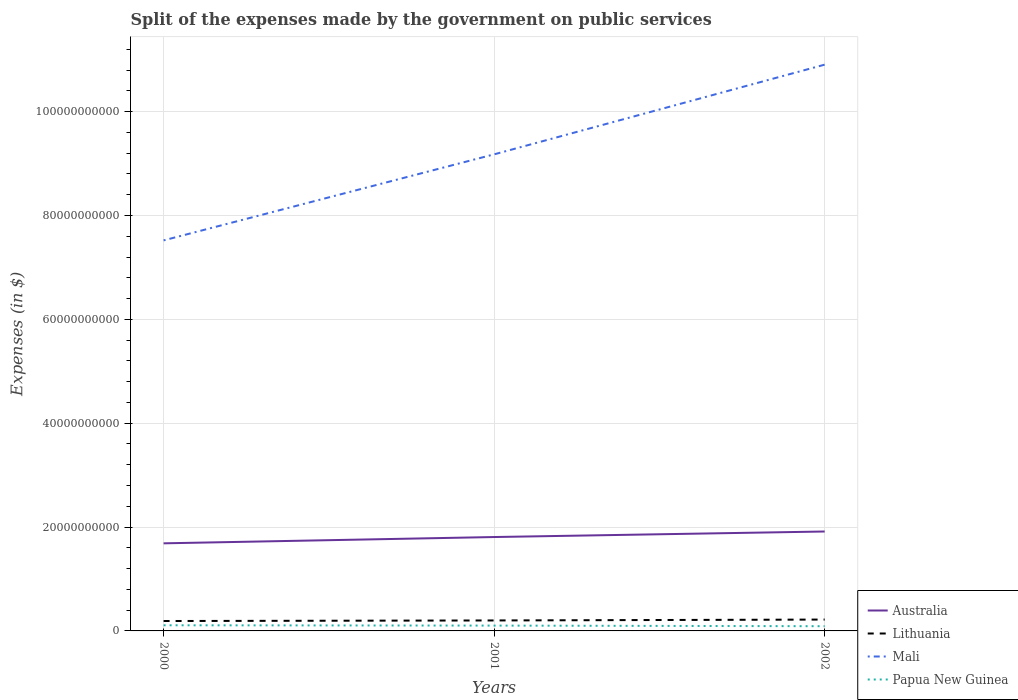How many different coloured lines are there?
Offer a terse response. 4. Across all years, what is the maximum expenses made by the government on public services in Mali?
Your answer should be compact. 7.52e+1. What is the total expenses made by the government on public services in Papua New Guinea in the graph?
Offer a terse response. 6.18e+07. What is the difference between the highest and the second highest expenses made by the government on public services in Australia?
Keep it short and to the point. 2.28e+09. What is the difference between the highest and the lowest expenses made by the government on public services in Papua New Guinea?
Your response must be concise. 2. Is the expenses made by the government on public services in Papua New Guinea strictly greater than the expenses made by the government on public services in Lithuania over the years?
Your response must be concise. Yes. What is the difference between two consecutive major ticks on the Y-axis?
Give a very brief answer. 2.00e+1. Are the values on the major ticks of Y-axis written in scientific E-notation?
Your answer should be compact. No. Does the graph contain grids?
Your answer should be very brief. Yes. Where does the legend appear in the graph?
Your answer should be compact. Bottom right. How are the legend labels stacked?
Give a very brief answer. Vertical. What is the title of the graph?
Your response must be concise. Split of the expenses made by the government on public services. Does "Andorra" appear as one of the legend labels in the graph?
Provide a succinct answer. No. What is the label or title of the X-axis?
Your response must be concise. Years. What is the label or title of the Y-axis?
Make the answer very short. Expenses (in $). What is the Expenses (in $) of Australia in 2000?
Make the answer very short. 1.69e+1. What is the Expenses (in $) in Lithuania in 2000?
Offer a terse response. 1.91e+09. What is the Expenses (in $) in Mali in 2000?
Your response must be concise. 7.52e+1. What is the Expenses (in $) of Papua New Guinea in 2000?
Offer a very short reply. 1.09e+09. What is the Expenses (in $) of Australia in 2001?
Provide a short and direct response. 1.81e+1. What is the Expenses (in $) in Lithuania in 2001?
Offer a very short reply. 2.02e+09. What is the Expenses (in $) in Mali in 2001?
Offer a terse response. 9.18e+1. What is the Expenses (in $) in Papua New Guinea in 2001?
Your response must be concise. 1.03e+09. What is the Expenses (in $) in Australia in 2002?
Give a very brief answer. 1.91e+1. What is the Expenses (in $) in Lithuania in 2002?
Provide a succinct answer. 2.19e+09. What is the Expenses (in $) of Mali in 2002?
Provide a short and direct response. 1.09e+11. What is the Expenses (in $) in Papua New Guinea in 2002?
Give a very brief answer. 9.07e+08. Across all years, what is the maximum Expenses (in $) in Australia?
Offer a terse response. 1.91e+1. Across all years, what is the maximum Expenses (in $) in Lithuania?
Your answer should be very brief. 2.19e+09. Across all years, what is the maximum Expenses (in $) of Mali?
Offer a terse response. 1.09e+11. Across all years, what is the maximum Expenses (in $) in Papua New Guinea?
Ensure brevity in your answer.  1.09e+09. Across all years, what is the minimum Expenses (in $) of Australia?
Keep it short and to the point. 1.69e+1. Across all years, what is the minimum Expenses (in $) in Lithuania?
Your answer should be compact. 1.91e+09. Across all years, what is the minimum Expenses (in $) of Mali?
Ensure brevity in your answer.  7.52e+1. Across all years, what is the minimum Expenses (in $) of Papua New Guinea?
Provide a succinct answer. 9.07e+08. What is the total Expenses (in $) in Australia in the graph?
Your answer should be compact. 5.41e+1. What is the total Expenses (in $) of Lithuania in the graph?
Your response must be concise. 6.11e+09. What is the total Expenses (in $) in Mali in the graph?
Offer a very short reply. 2.76e+11. What is the total Expenses (in $) of Papua New Guinea in the graph?
Offer a terse response. 3.02e+09. What is the difference between the Expenses (in $) of Australia in 2000 and that in 2001?
Make the answer very short. -1.21e+09. What is the difference between the Expenses (in $) in Lithuania in 2000 and that in 2001?
Provide a short and direct response. -1.09e+08. What is the difference between the Expenses (in $) of Mali in 2000 and that in 2001?
Keep it short and to the point. -1.66e+1. What is the difference between the Expenses (in $) in Papua New Guinea in 2000 and that in 2001?
Offer a very short reply. 6.18e+07. What is the difference between the Expenses (in $) in Australia in 2000 and that in 2002?
Ensure brevity in your answer.  -2.28e+09. What is the difference between the Expenses (in $) in Lithuania in 2000 and that in 2002?
Ensure brevity in your answer.  -2.80e+08. What is the difference between the Expenses (in $) in Mali in 2000 and that in 2002?
Provide a short and direct response. -3.38e+1. What is the difference between the Expenses (in $) of Papua New Guinea in 2000 and that in 2002?
Offer a very short reply. 1.80e+08. What is the difference between the Expenses (in $) of Australia in 2001 and that in 2002?
Offer a very short reply. -1.06e+09. What is the difference between the Expenses (in $) in Lithuania in 2001 and that in 2002?
Offer a terse response. -1.71e+08. What is the difference between the Expenses (in $) of Mali in 2001 and that in 2002?
Your answer should be very brief. -1.73e+1. What is the difference between the Expenses (in $) in Papua New Guinea in 2001 and that in 2002?
Provide a succinct answer. 1.18e+08. What is the difference between the Expenses (in $) of Australia in 2000 and the Expenses (in $) of Lithuania in 2001?
Provide a succinct answer. 1.49e+1. What is the difference between the Expenses (in $) in Australia in 2000 and the Expenses (in $) in Mali in 2001?
Offer a terse response. -7.49e+1. What is the difference between the Expenses (in $) in Australia in 2000 and the Expenses (in $) in Papua New Guinea in 2001?
Give a very brief answer. 1.58e+1. What is the difference between the Expenses (in $) of Lithuania in 2000 and the Expenses (in $) of Mali in 2001?
Your answer should be compact. -8.99e+1. What is the difference between the Expenses (in $) of Lithuania in 2000 and the Expenses (in $) of Papua New Guinea in 2001?
Your response must be concise. 8.82e+08. What is the difference between the Expenses (in $) of Mali in 2000 and the Expenses (in $) of Papua New Guinea in 2001?
Offer a terse response. 7.42e+1. What is the difference between the Expenses (in $) in Australia in 2000 and the Expenses (in $) in Lithuania in 2002?
Your response must be concise. 1.47e+1. What is the difference between the Expenses (in $) of Australia in 2000 and the Expenses (in $) of Mali in 2002?
Offer a very short reply. -9.22e+1. What is the difference between the Expenses (in $) in Australia in 2000 and the Expenses (in $) in Papua New Guinea in 2002?
Make the answer very short. 1.60e+1. What is the difference between the Expenses (in $) of Lithuania in 2000 and the Expenses (in $) of Mali in 2002?
Provide a succinct answer. -1.07e+11. What is the difference between the Expenses (in $) in Lithuania in 2000 and the Expenses (in $) in Papua New Guinea in 2002?
Ensure brevity in your answer.  1.00e+09. What is the difference between the Expenses (in $) in Mali in 2000 and the Expenses (in $) in Papua New Guinea in 2002?
Provide a short and direct response. 7.43e+1. What is the difference between the Expenses (in $) of Australia in 2001 and the Expenses (in $) of Lithuania in 2002?
Ensure brevity in your answer.  1.59e+1. What is the difference between the Expenses (in $) of Australia in 2001 and the Expenses (in $) of Mali in 2002?
Give a very brief answer. -9.10e+1. What is the difference between the Expenses (in $) in Australia in 2001 and the Expenses (in $) in Papua New Guinea in 2002?
Give a very brief answer. 1.72e+1. What is the difference between the Expenses (in $) of Lithuania in 2001 and the Expenses (in $) of Mali in 2002?
Your response must be concise. -1.07e+11. What is the difference between the Expenses (in $) in Lithuania in 2001 and the Expenses (in $) in Papua New Guinea in 2002?
Make the answer very short. 1.11e+09. What is the difference between the Expenses (in $) of Mali in 2001 and the Expenses (in $) of Papua New Guinea in 2002?
Provide a short and direct response. 9.09e+1. What is the average Expenses (in $) in Australia per year?
Your answer should be very brief. 1.80e+1. What is the average Expenses (in $) in Lithuania per year?
Your answer should be compact. 2.04e+09. What is the average Expenses (in $) in Mali per year?
Ensure brevity in your answer.  9.20e+1. What is the average Expenses (in $) in Papua New Guinea per year?
Ensure brevity in your answer.  1.01e+09. In the year 2000, what is the difference between the Expenses (in $) in Australia and Expenses (in $) in Lithuania?
Offer a very short reply. 1.50e+1. In the year 2000, what is the difference between the Expenses (in $) in Australia and Expenses (in $) in Mali?
Keep it short and to the point. -5.83e+1. In the year 2000, what is the difference between the Expenses (in $) in Australia and Expenses (in $) in Papua New Guinea?
Make the answer very short. 1.58e+1. In the year 2000, what is the difference between the Expenses (in $) in Lithuania and Expenses (in $) in Mali?
Your answer should be very brief. -7.33e+1. In the year 2000, what is the difference between the Expenses (in $) of Lithuania and Expenses (in $) of Papua New Guinea?
Your answer should be compact. 8.20e+08. In the year 2000, what is the difference between the Expenses (in $) of Mali and Expenses (in $) of Papua New Guinea?
Offer a terse response. 7.41e+1. In the year 2001, what is the difference between the Expenses (in $) of Australia and Expenses (in $) of Lithuania?
Provide a succinct answer. 1.61e+1. In the year 2001, what is the difference between the Expenses (in $) of Australia and Expenses (in $) of Mali?
Provide a succinct answer. -7.37e+1. In the year 2001, what is the difference between the Expenses (in $) of Australia and Expenses (in $) of Papua New Guinea?
Your answer should be compact. 1.71e+1. In the year 2001, what is the difference between the Expenses (in $) in Lithuania and Expenses (in $) in Mali?
Your answer should be compact. -8.98e+1. In the year 2001, what is the difference between the Expenses (in $) in Lithuania and Expenses (in $) in Papua New Guinea?
Your answer should be very brief. 9.91e+08. In the year 2001, what is the difference between the Expenses (in $) in Mali and Expenses (in $) in Papua New Guinea?
Keep it short and to the point. 9.07e+1. In the year 2002, what is the difference between the Expenses (in $) in Australia and Expenses (in $) in Lithuania?
Your response must be concise. 1.70e+1. In the year 2002, what is the difference between the Expenses (in $) in Australia and Expenses (in $) in Mali?
Make the answer very short. -8.99e+1. In the year 2002, what is the difference between the Expenses (in $) in Australia and Expenses (in $) in Papua New Guinea?
Make the answer very short. 1.82e+1. In the year 2002, what is the difference between the Expenses (in $) of Lithuania and Expenses (in $) of Mali?
Offer a very short reply. -1.07e+11. In the year 2002, what is the difference between the Expenses (in $) of Lithuania and Expenses (in $) of Papua New Guinea?
Make the answer very short. 1.28e+09. In the year 2002, what is the difference between the Expenses (in $) in Mali and Expenses (in $) in Papua New Guinea?
Your answer should be very brief. 1.08e+11. What is the ratio of the Expenses (in $) in Australia in 2000 to that in 2001?
Provide a short and direct response. 0.93. What is the ratio of the Expenses (in $) in Lithuania in 2000 to that in 2001?
Provide a succinct answer. 0.95. What is the ratio of the Expenses (in $) of Mali in 2000 to that in 2001?
Give a very brief answer. 0.82. What is the ratio of the Expenses (in $) of Papua New Guinea in 2000 to that in 2001?
Provide a short and direct response. 1.06. What is the ratio of the Expenses (in $) of Australia in 2000 to that in 2002?
Provide a succinct answer. 0.88. What is the ratio of the Expenses (in $) in Lithuania in 2000 to that in 2002?
Make the answer very short. 0.87. What is the ratio of the Expenses (in $) in Mali in 2000 to that in 2002?
Offer a terse response. 0.69. What is the ratio of the Expenses (in $) in Papua New Guinea in 2000 to that in 2002?
Your answer should be very brief. 1.2. What is the ratio of the Expenses (in $) of Lithuania in 2001 to that in 2002?
Your response must be concise. 0.92. What is the ratio of the Expenses (in $) in Mali in 2001 to that in 2002?
Your response must be concise. 0.84. What is the ratio of the Expenses (in $) of Papua New Guinea in 2001 to that in 2002?
Provide a succinct answer. 1.13. What is the difference between the highest and the second highest Expenses (in $) of Australia?
Make the answer very short. 1.06e+09. What is the difference between the highest and the second highest Expenses (in $) of Lithuania?
Your answer should be compact. 1.71e+08. What is the difference between the highest and the second highest Expenses (in $) of Mali?
Provide a short and direct response. 1.73e+1. What is the difference between the highest and the second highest Expenses (in $) of Papua New Guinea?
Provide a short and direct response. 6.18e+07. What is the difference between the highest and the lowest Expenses (in $) of Australia?
Your answer should be very brief. 2.28e+09. What is the difference between the highest and the lowest Expenses (in $) in Lithuania?
Your answer should be very brief. 2.80e+08. What is the difference between the highest and the lowest Expenses (in $) in Mali?
Ensure brevity in your answer.  3.38e+1. What is the difference between the highest and the lowest Expenses (in $) of Papua New Guinea?
Offer a very short reply. 1.80e+08. 